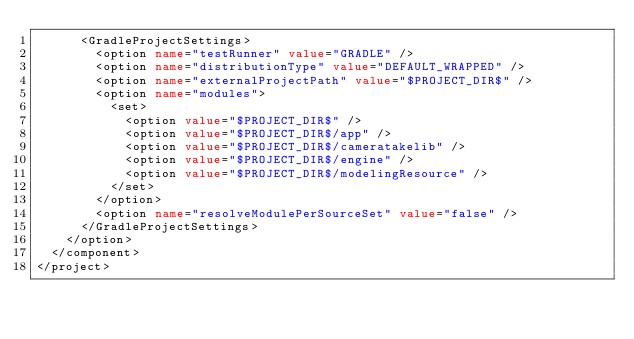Convert code to text. <code><loc_0><loc_0><loc_500><loc_500><_XML_>      <GradleProjectSettings>
        <option name="testRunner" value="GRADLE" />
        <option name="distributionType" value="DEFAULT_WRAPPED" />
        <option name="externalProjectPath" value="$PROJECT_DIR$" />
        <option name="modules">
          <set>
            <option value="$PROJECT_DIR$" />
            <option value="$PROJECT_DIR$/app" />
            <option value="$PROJECT_DIR$/cameratakelib" />
            <option value="$PROJECT_DIR$/engine" />
            <option value="$PROJECT_DIR$/modelingResource" />
          </set>
        </option>
        <option name="resolveModulePerSourceSet" value="false" />
      </GradleProjectSettings>
    </option>
  </component>
</project></code> 